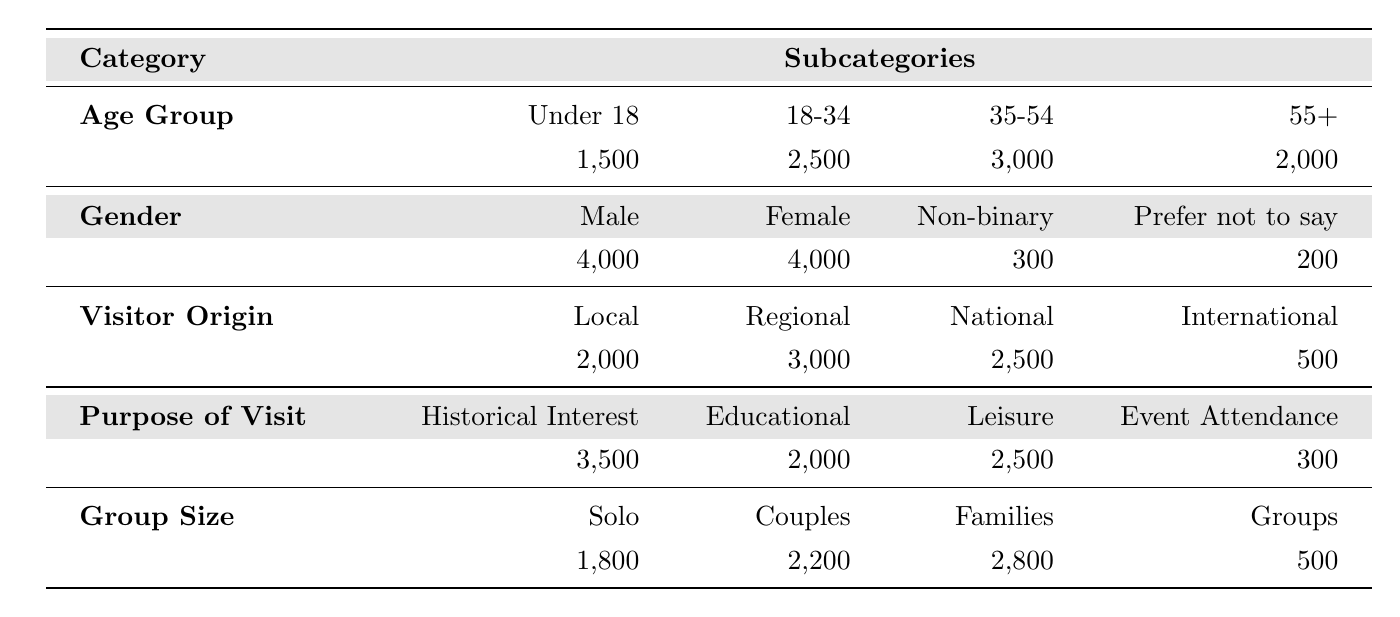What is the total number of visitors aged 35 to 54? The table states that there are 3,000 visitors in the age group 35 to 54.
Answer: 3000 How many visitors prefer not to say their gender? The table shows that 200 visitors prefer not to say their gender.
Answer: 200 What is the total number of local and international visitors combined? Adding the local visitors (2,000) and international visitors (500) gives 2,000 + 500 = 2,500.
Answer: 2500 Which age group has the highest number of visitors? The age group with the highest number of visitors is 35 to 54, with 3,000.
Answer: 35 to 54 What percentage of visitors are under the age of 18? To find the percentage, take the number of visitors under 18 (1,500), divide by the total number of visitors (1,500 + 2,500 + 3,000 + 2,000 = 9,000). The calculation is (1,500 / 9,000) * 100 = 16.67%.
Answer: 16.67% How many more females visited than non-binary individuals? The number of female visitors is 4,000 and non-binary visitors is 300. The difference is 4,000 - 300 = 3,700.
Answer: 3700 What is the average group size for visitors? First, sum the group sizes: solo (1,800) + couples (2,200) + families (2,800) + groups (500) = 7,300. Then divide by the number of groups (4) to get the average: 7,300 / 4 = 1,825.
Answer: 1825 Are there more visitors interested in historical interest or educational activities? The number of visitors interested in historical interest is 3,500, and those interested in educational activities is 2,000. Since 3,500 > 2,000, there are more interested in historical interest.
Answer: Yes What is the combined total of couples and families visiting? Adding couples (2,200) and families (2,800) gives a total of 2,200 + 2,800 = 5,000.
Answer: 5000 Which visitor origin category had the lowest number of visitors? The visitor origin with the lowest count is international visitors with 500.
Answer: International 